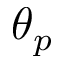Convert formula to latex. <formula><loc_0><loc_0><loc_500><loc_500>\theta _ { p }</formula> 